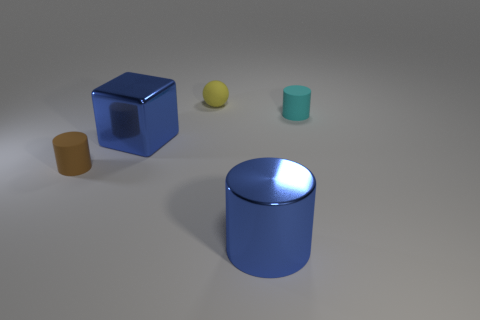The ball is what color?
Make the answer very short. Yellow. What number of other things are there of the same size as the yellow thing?
Keep it short and to the point. 2. There is a ball that is behind the large blue metal cylinder that is to the right of the brown object; what is its material?
Give a very brief answer. Rubber. There is a cyan cylinder; is its size the same as the blue thing that is on the right side of the yellow rubber object?
Your answer should be compact. No. Is there another large cylinder that has the same color as the large metallic cylinder?
Make the answer very short. No. What number of small objects are either cyan things or matte balls?
Make the answer very short. 2. How many metal blocks are there?
Provide a succinct answer. 1. There is a tiny cylinder that is on the left side of the tiny cyan cylinder; what is it made of?
Ensure brevity in your answer.  Rubber. Are there any small matte cylinders behind the tiny cyan rubber cylinder?
Your response must be concise. No. Does the yellow matte thing have the same size as the blue shiny block?
Provide a short and direct response. No. 